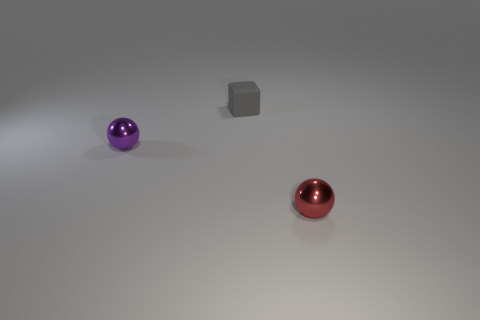Is the number of purple cylinders less than the number of tiny red balls?
Your answer should be very brief. Yes. There is a red metal sphere that is on the right side of the metallic thing that is behind the sphere that is on the right side of the small cube; what size is it?
Provide a succinct answer. Small. How many other objects are the same color as the tiny matte thing?
Provide a succinct answer. 0. What number of things are green matte cubes or red balls?
Keep it short and to the point. 1. The metal sphere to the right of the gray matte thing is what color?
Give a very brief answer. Red. Are there fewer shiny spheres that are in front of the block than matte things?
Provide a succinct answer. No. Do the small red object and the cube have the same material?
Make the answer very short. No. How many objects are either things to the right of the tiny purple shiny thing or metallic balls behind the red object?
Your answer should be very brief. 3. Is there a rubber thing that has the same size as the red metal thing?
Provide a succinct answer. Yes. There is another tiny metal thing that is the same shape as the small red thing; what color is it?
Keep it short and to the point. Purple. 